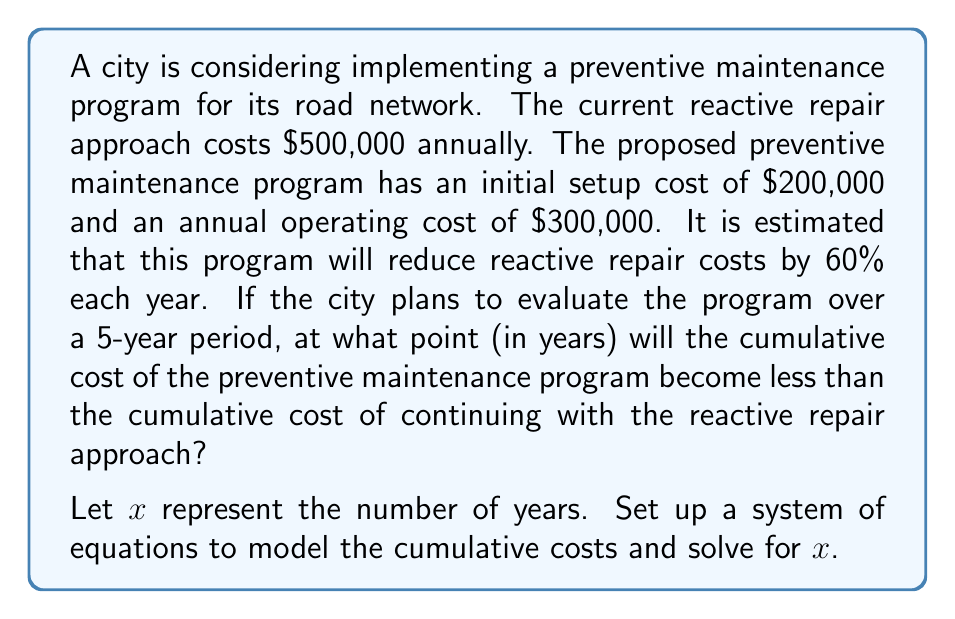What is the answer to this math problem? To solve this problem, we need to set up equations for the cumulative costs of both approaches over $x$ years:

1. Reactive Repair Approach (current method):
   Annual cost = $500,000
   Cumulative cost over $x$ years = $500,000x$

2. Preventive Maintenance Program:
   Initial setup cost = $200,000
   Annual operating cost = $300,000
   Reduced reactive repair cost = $500,000 * (1 - 0.60) = $200,000
   
   Cumulative cost over $x$ years = $200,000 + (300,000 + 200,000)x$

We want to find when the cumulative cost of the preventive maintenance program becomes less than the reactive repair approach. This can be expressed as:

$$200,000 + (300,000 + 200,000)x < 500,000x$$

Now, let's solve this inequality:

$$200,000 + 500,000x < 500,000x$$
$$200,000 < 0x$$

This is always false, meaning the preventive maintenance program is always less expensive. To find the exact break-even point, we set up an equation:

$$200,000 + 500,000x = 500,000x$$
$$200,000 = 0x$$

This equation has no solution, confirming that the preventive maintenance program is immediately more cost-effective.

To verify, let's compare the costs after one year:

Reactive Repair: $500,000
Preventive Maintenance: $200,000 + $500,000 = $700,000

After two years:
Reactive Repair: $1,000,000
Preventive Maintenance: $200,000 + $500,000 * 2 = $1,200,000

After three years:
Reactive Repair: $1,500,000
Preventive Maintenance: $200,000 + $500,000 * 3 = $1,700,000

The preventive maintenance program becomes less expensive than the reactive approach immediately after implementation and remains so for all subsequent years.
Answer: The preventive maintenance program becomes less expensive than the reactive repair approach immediately after implementation (year 0). There is no break-even point in years, as the preventive maintenance program is more cost-effective from the start. 